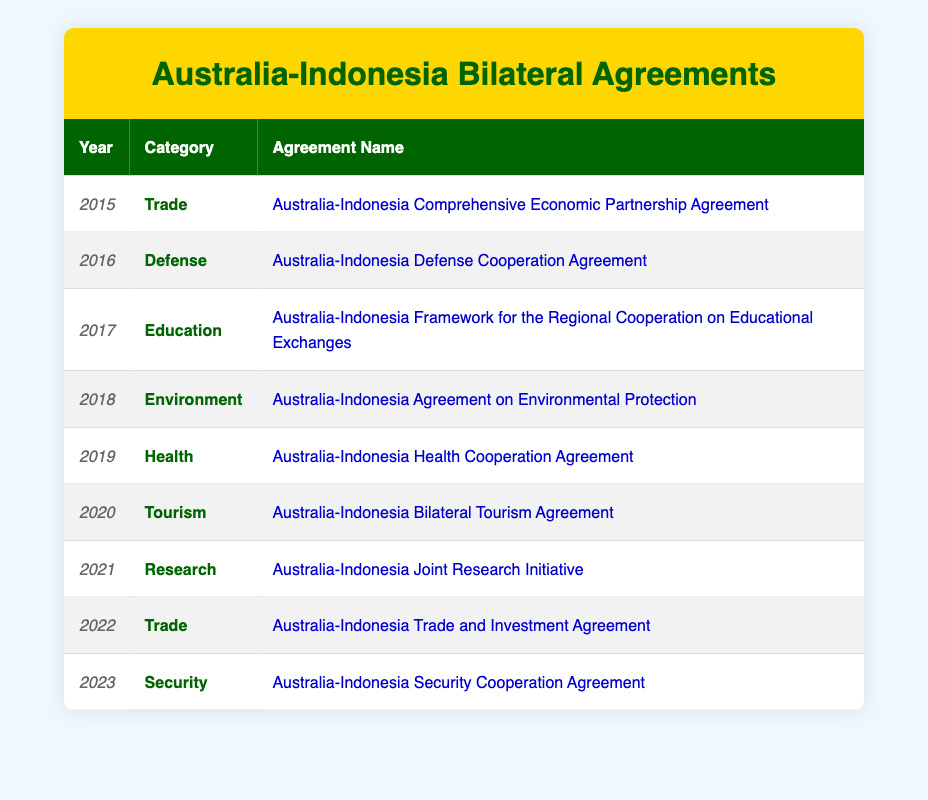What is the total number of bilateral agreements signed in the year 2020? There is one agreement listed for the year 2020, which is the Australia-Indonesia Bilateral Tourism Agreement.
Answer: 1 How many agreements were signed under the category of Trade? There are two agreements listed under the Trade category: the Australia-Indonesia Comprehensive Economic Partnership Agreement in 2015 and the Australia-Indonesia Trade and Investment Agreement in 2022.
Answer: 2 Did Australia and your country sign a defense agreement in 2016? Yes, the Australia-Indonesia Defense Cooperation Agreement was signed in 2016.
Answer: Yes What has been the trend in the number of bilateral agreements signed per year from 2015 to 2023? There is one agreement signed in each year from 2015 to 2023. Thus, the trend indicates consistency in signing one agreement annually.
Answer: Consistent Which category had the most recent agreement signed, and what is the name of that agreement? The most recent agreement signed in 2023 falls under the Security category, named the Australia-Indonesia Security Cooperation Agreement.
Answer: Security: Australia-Indonesia Security Cooperation Agreement How many categories have had agreements signed in both 2015 and 2022? The category of Trade has agreements signed in both years: 2015 (Australia-Indonesia Comprehensive Economic Partnership Agreement) and 2022 (Australia-Indonesia Trade and Investment Agreement). There are no other categories that meet this criterion.
Answer: 1 Which year saw the signing of the Australia-Indonesia Health Cooperation Agreement, and what category does it belong to? The Australia-Indonesia Health Cooperation Agreement was signed in 2019, and it belongs to the Health category.
Answer: 2019, Health Is there a year in which no agreements were signed? No, every year from 2015 to 2023 has at least one agreement signed.
Answer: No 